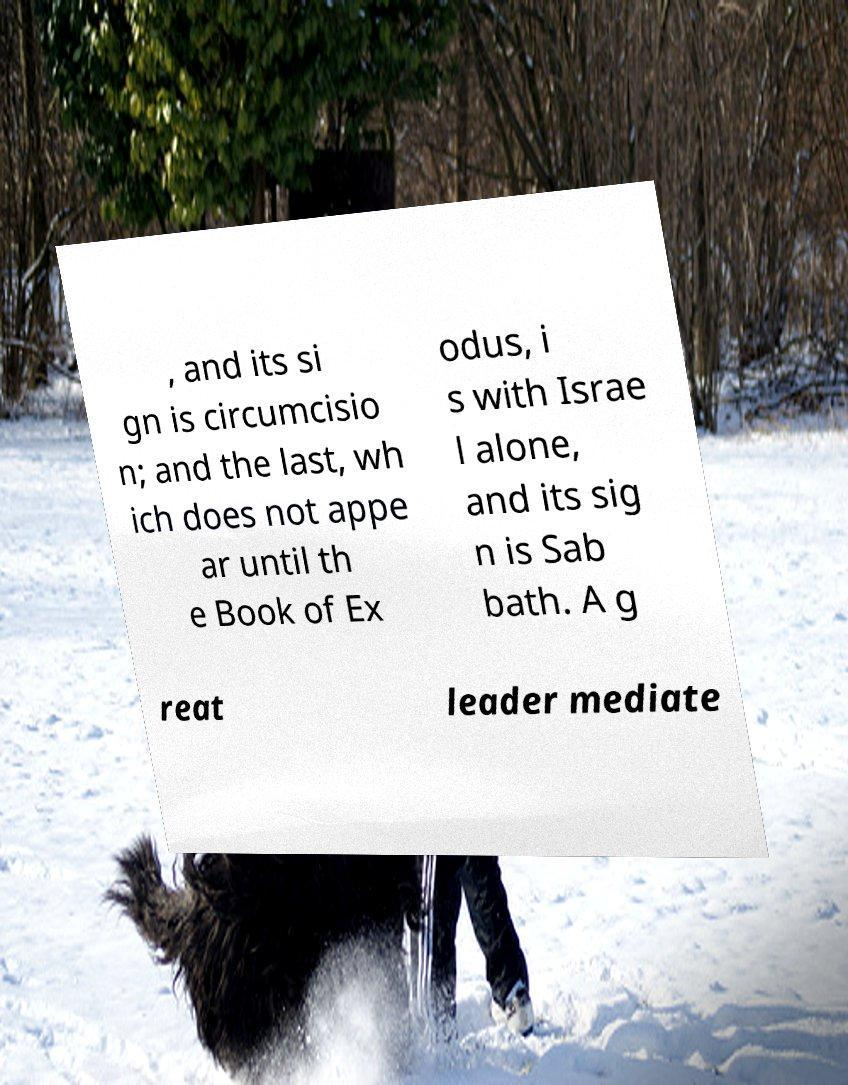Could you assist in decoding the text presented in this image and type it out clearly? , and its si gn is circumcisio n; and the last, wh ich does not appe ar until th e Book of Ex odus, i s with Israe l alone, and its sig n is Sab bath. A g reat leader mediate 